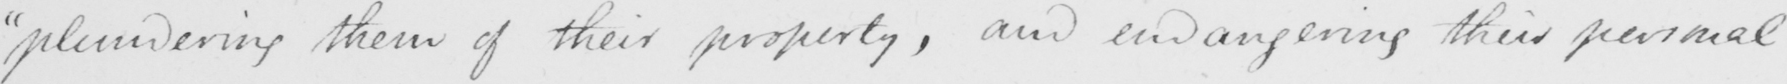Transcribe the text shown in this historical manuscript line. " plundering them of their property , and endangering their personal 